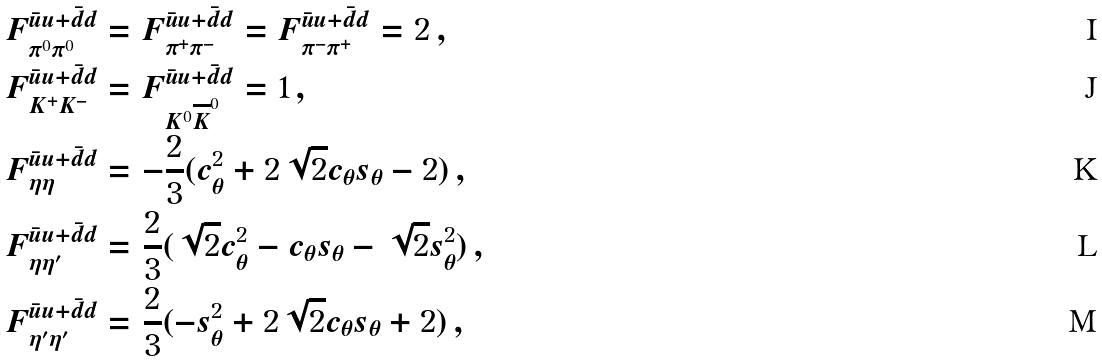Convert formula to latex. <formula><loc_0><loc_0><loc_500><loc_500>F _ { \pi ^ { 0 } \pi ^ { 0 } } ^ { \bar { u } u + \bar { d } d } & = F _ { \pi ^ { + } \pi ^ { - } } ^ { \bar { u } u + \bar { d } d } = F _ { \pi ^ { - } \pi ^ { + } } ^ { \bar { u } u + \bar { d } d } = 2 \, , \\ F _ { K ^ { + } K ^ { - } } ^ { \bar { u } u + \bar { d } d } & = F _ { K ^ { 0 } \overline { K } ^ { 0 } } ^ { \bar { u } u + \bar { d } d } = 1 \, , \\ F _ { \eta \eta } ^ { \bar { u } u + \bar { d } d } & = - \frac { 2 } { 3 } ( c _ { \theta } ^ { 2 } + 2 \sqrt { 2 } c _ { \theta } s _ { \theta } - 2 ) \, , \\ F _ { \eta \eta ^ { \prime } } ^ { \bar { u } u + \bar { d } d } & = \frac { 2 } { 3 } ( \sqrt { 2 } c _ { \theta } ^ { 2 } - c _ { \theta } s _ { \theta } - \sqrt { 2 } s _ { \theta } ^ { 2 } ) \, , \\ F _ { \eta ^ { \prime } \eta ^ { \prime } } ^ { \bar { u } u + \bar { d } d } & = \frac { 2 } { 3 } ( - s _ { \theta } ^ { 2 } + 2 \sqrt { 2 } c _ { \theta } s _ { \theta } + 2 ) \, ,</formula> 